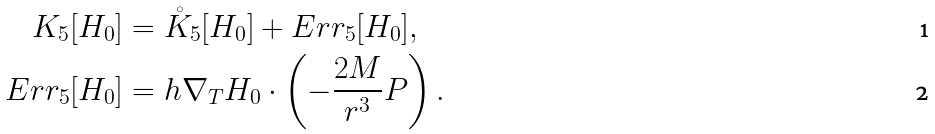<formula> <loc_0><loc_0><loc_500><loc_500>K _ { 5 } [ H _ { 0 } ] & = \mathring { K } _ { 5 } [ H _ { 0 } ] + E r r _ { 5 } [ H _ { 0 } ] , \\ E r r _ { 5 } [ H _ { 0 } ] & = h \nabla _ { T } H _ { 0 } \cdot \left ( - \frac { 2 M } { r ^ { 3 } } P \right ) .</formula> 